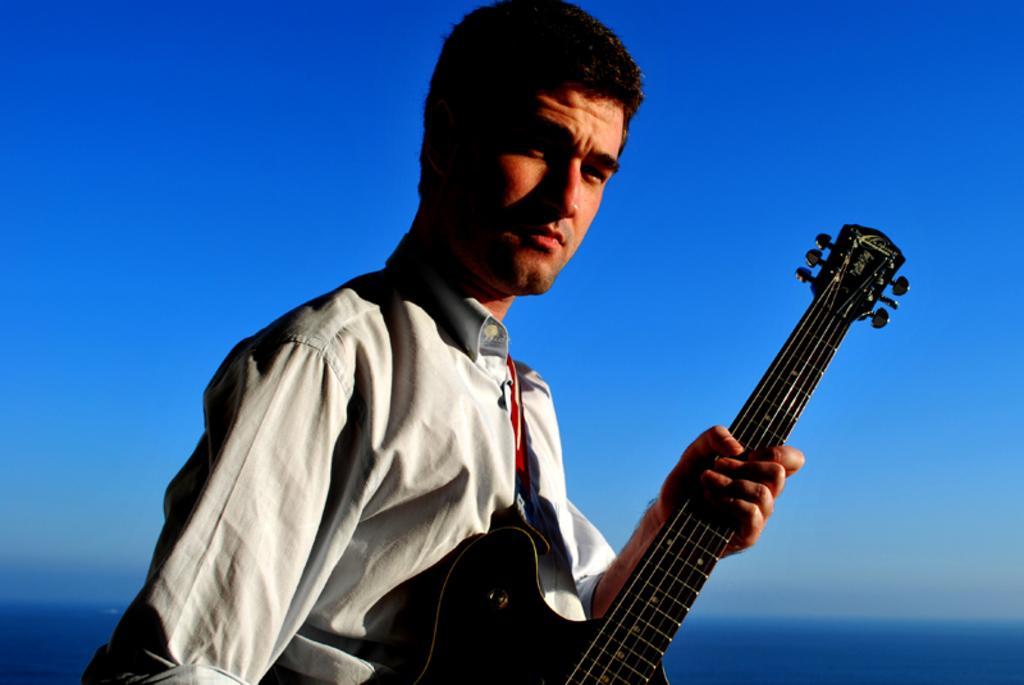Can you describe this image briefly? In the picture we can see a man wore white shirt and he is holding a guitar in the hand and in the back ground we can see a blue sky. 